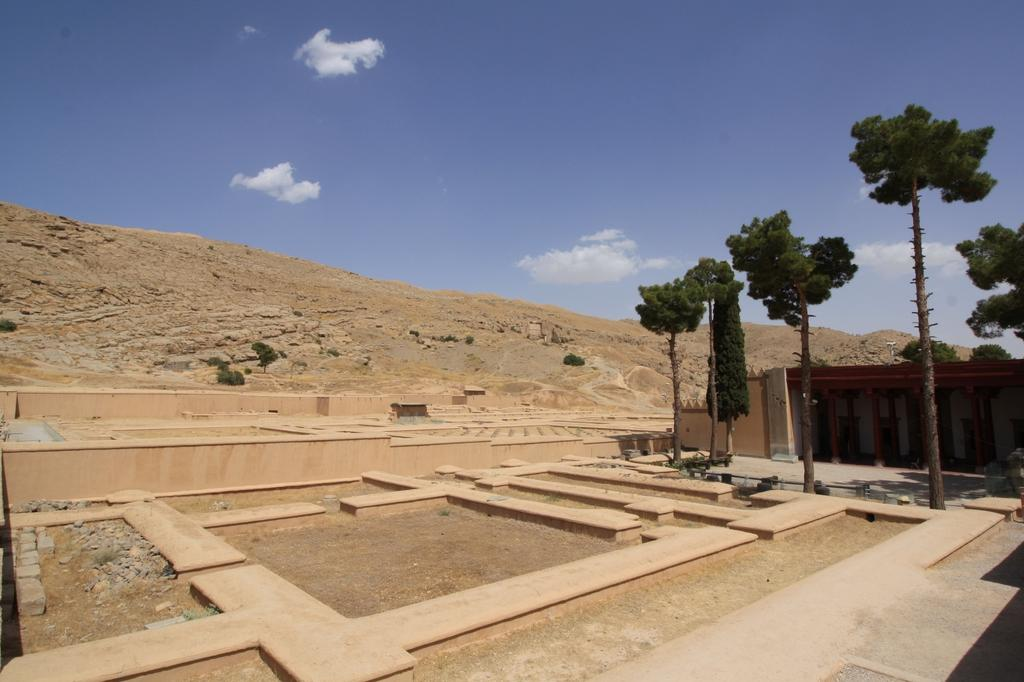What is the color and type of the foundation in the image? The foundation in the image is a brown color stone. What can be seen in the background of the image? There are two huge trees and a huge mountain visible in the background of the image. Where is the cub located in the image? There is no cub present in the image. What type of vase can be seen on the mountain in the image? There is no vase present on the mountain in the image. 